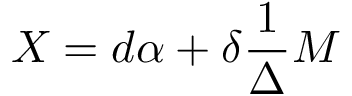Convert formula to latex. <formula><loc_0><loc_0><loc_500><loc_500>X = d \alpha + \delta \frac { 1 } { \Delta } M</formula> 